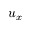Convert formula to latex. <formula><loc_0><loc_0><loc_500><loc_500>u _ { x }</formula> 